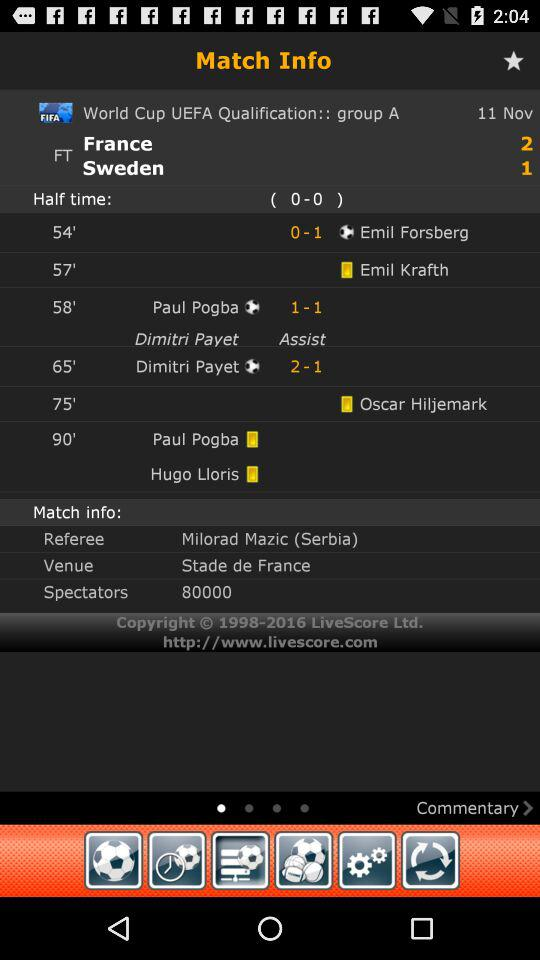Who is the referee? The referee is Milorad Mazic. 